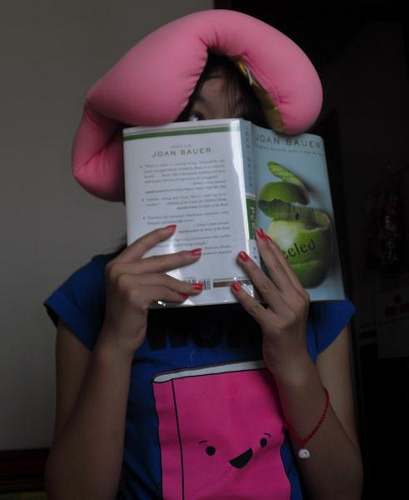<image>
Is there a pillow above the book? Yes. The pillow is positioned above the book in the vertical space, higher up in the scene. 